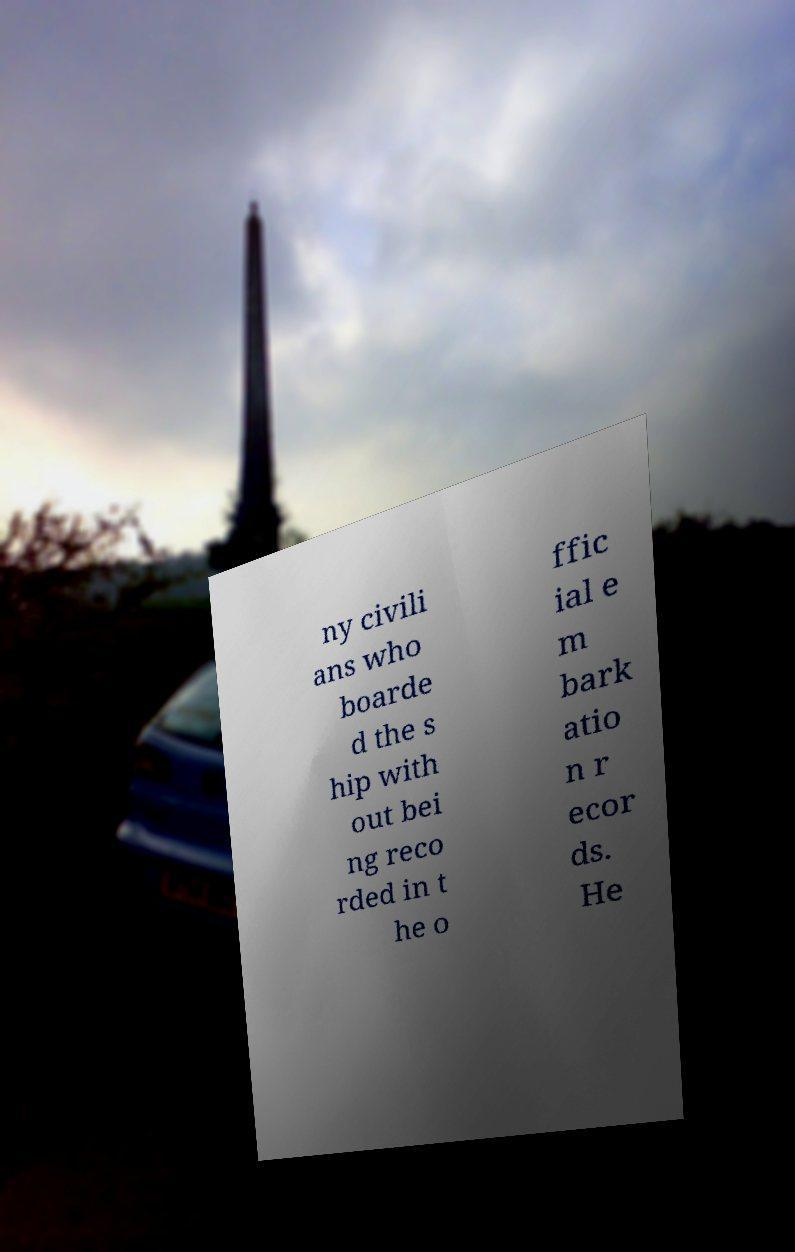Please read and relay the text visible in this image. What does it say? ny civili ans who boarde d the s hip with out bei ng reco rded in t he o ffic ial e m bark atio n r ecor ds. He 